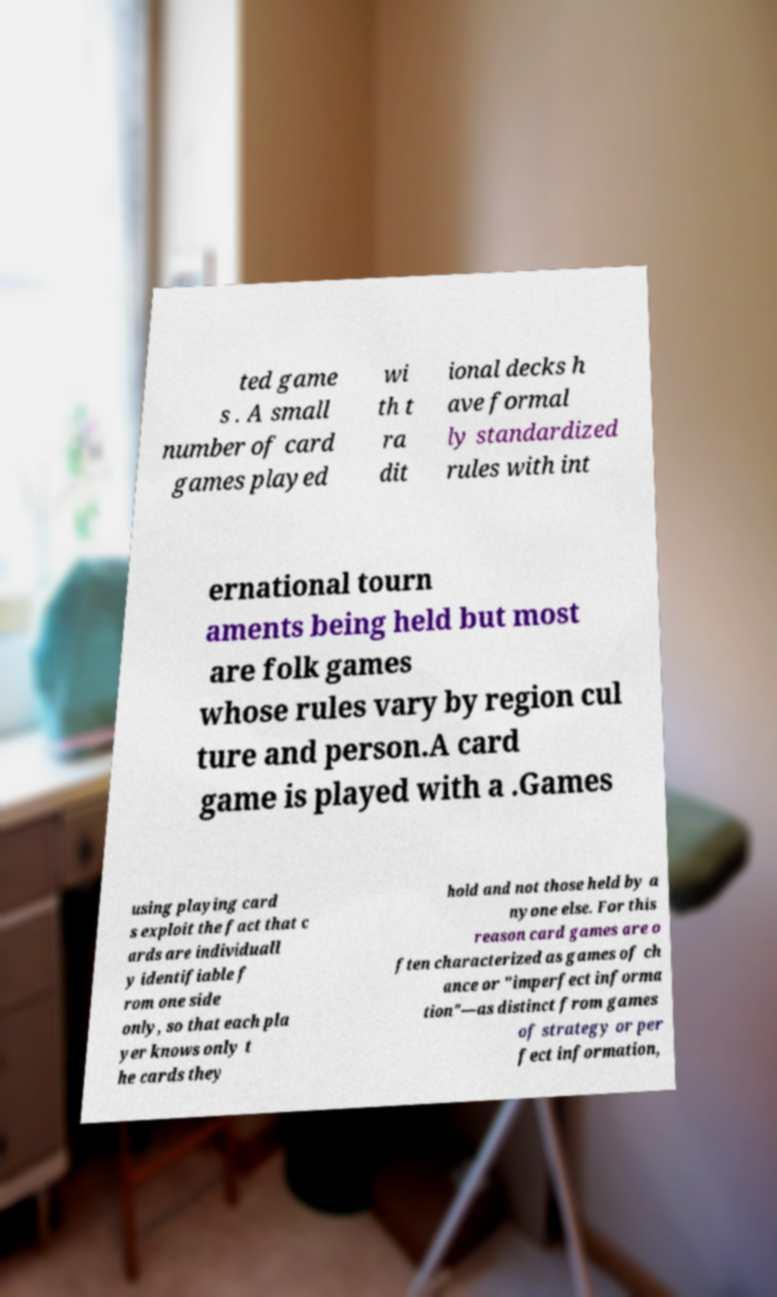Can you accurately transcribe the text from the provided image for me? ted game s . A small number of card games played wi th t ra dit ional decks h ave formal ly standardized rules with int ernational tourn aments being held but most are folk games whose rules vary by region cul ture and person.A card game is played with a .Games using playing card s exploit the fact that c ards are individuall y identifiable f rom one side only, so that each pla yer knows only t he cards they hold and not those held by a nyone else. For this reason card games are o ften characterized as games of ch ance or "imperfect informa tion"—as distinct from games of strategy or per fect information, 